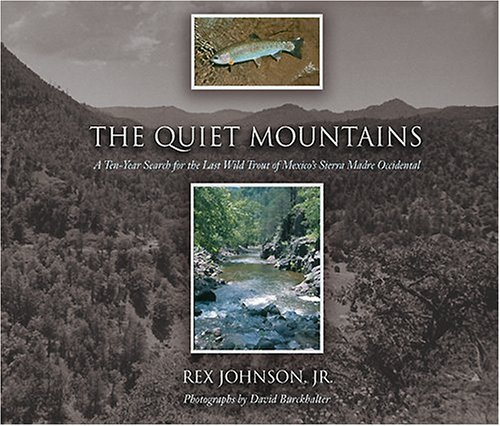Who might enjoy reading this book? This book is likely to be enjoyed by those who appreciate nature, adventure stories, angling enthusiasts, and individuals interested in environmental conservation. 